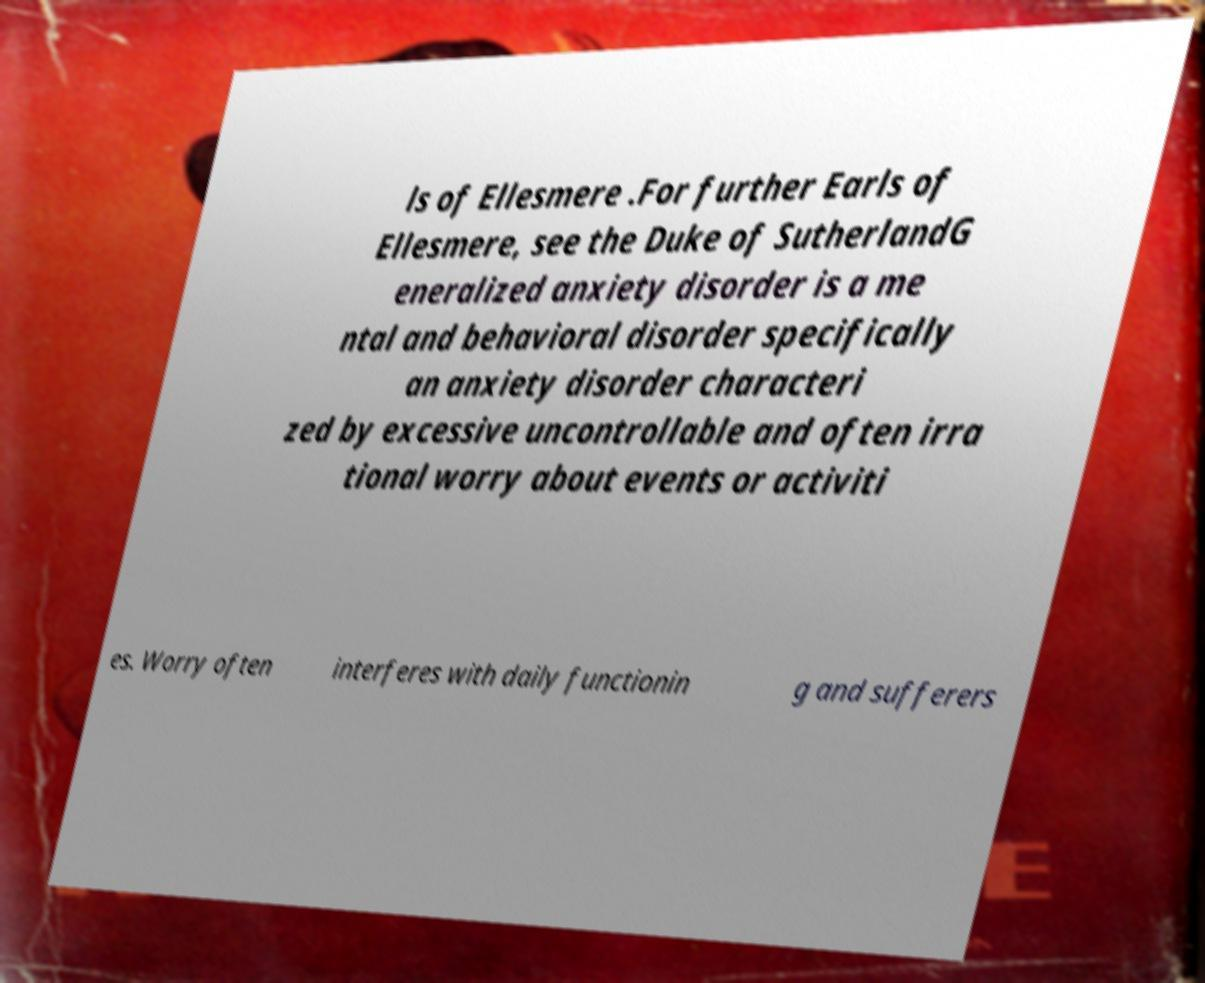Please read and relay the text visible in this image. What does it say? ls of Ellesmere .For further Earls of Ellesmere, see the Duke of SutherlandG eneralized anxiety disorder is a me ntal and behavioral disorder specifically an anxiety disorder characteri zed by excessive uncontrollable and often irra tional worry about events or activiti es. Worry often interferes with daily functionin g and sufferers 